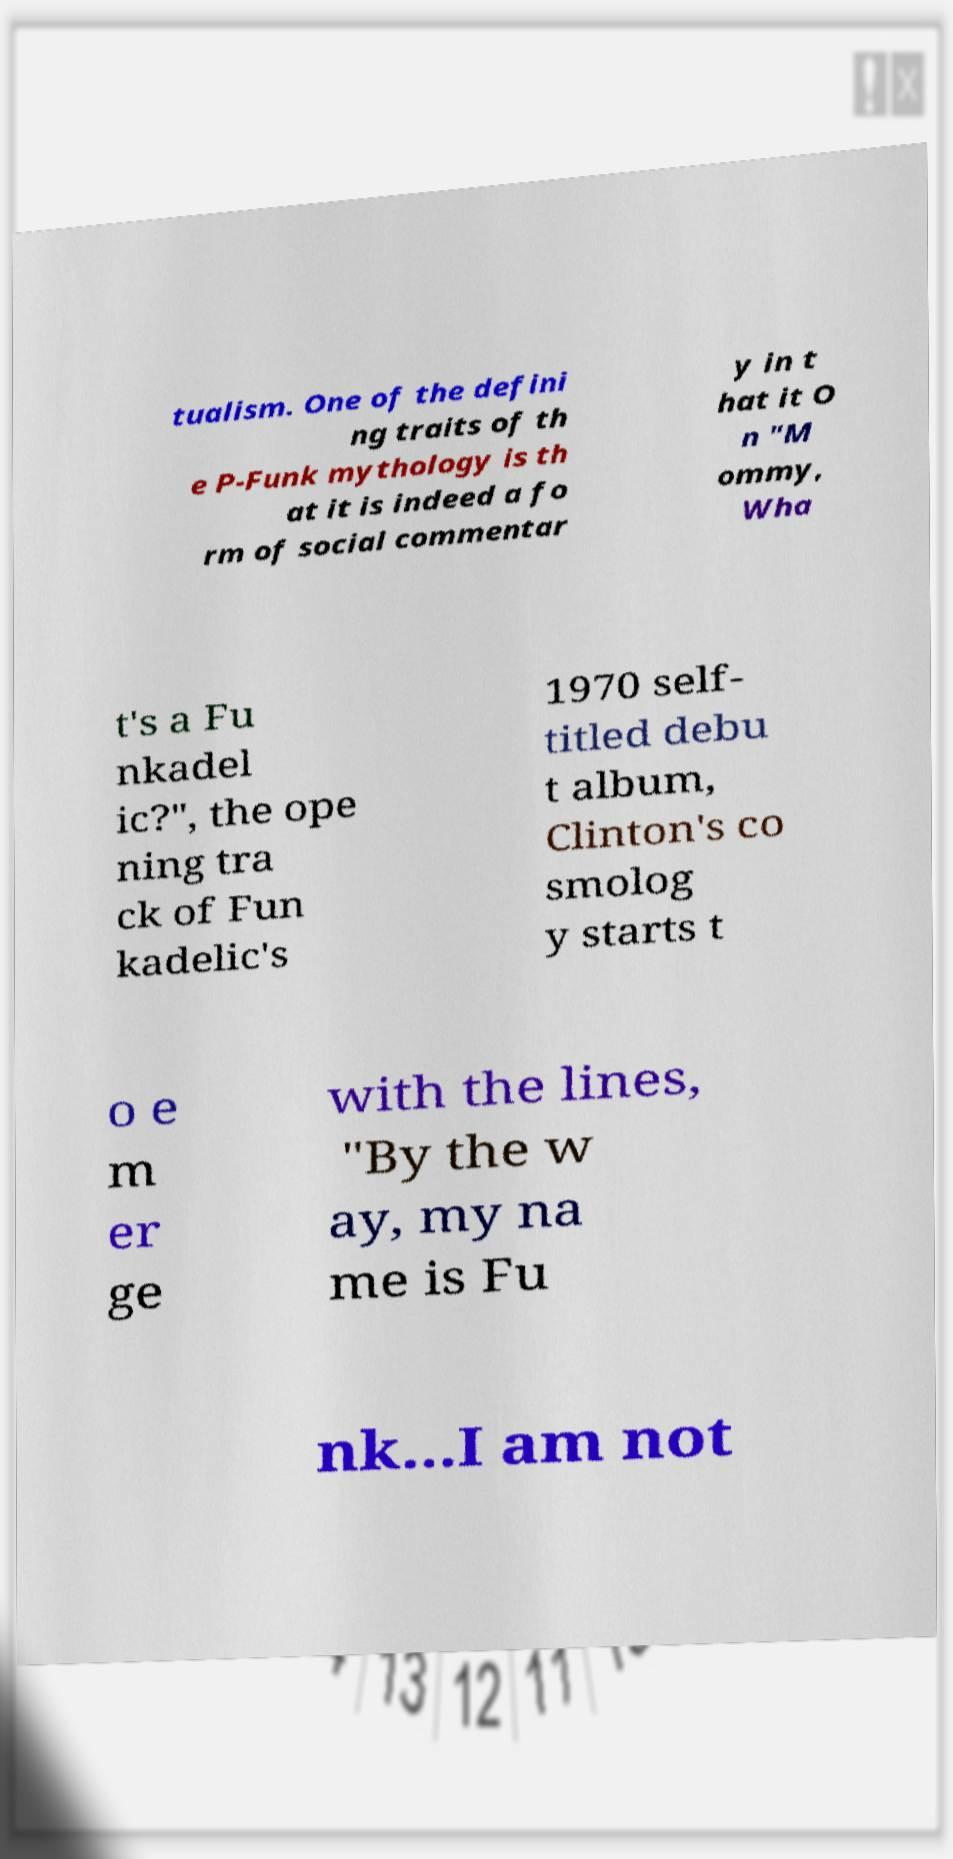Could you extract and type out the text from this image? tualism. One of the defini ng traits of th e P-Funk mythology is th at it is indeed a fo rm of social commentar y in t hat it O n "M ommy, Wha t's a Fu nkadel ic?", the ope ning tra ck of Fun kadelic's 1970 self- titled debu t album, Clinton's co smolog y starts t o e m er ge with the lines, "By the w ay, my na me is Fu nk...I am not 